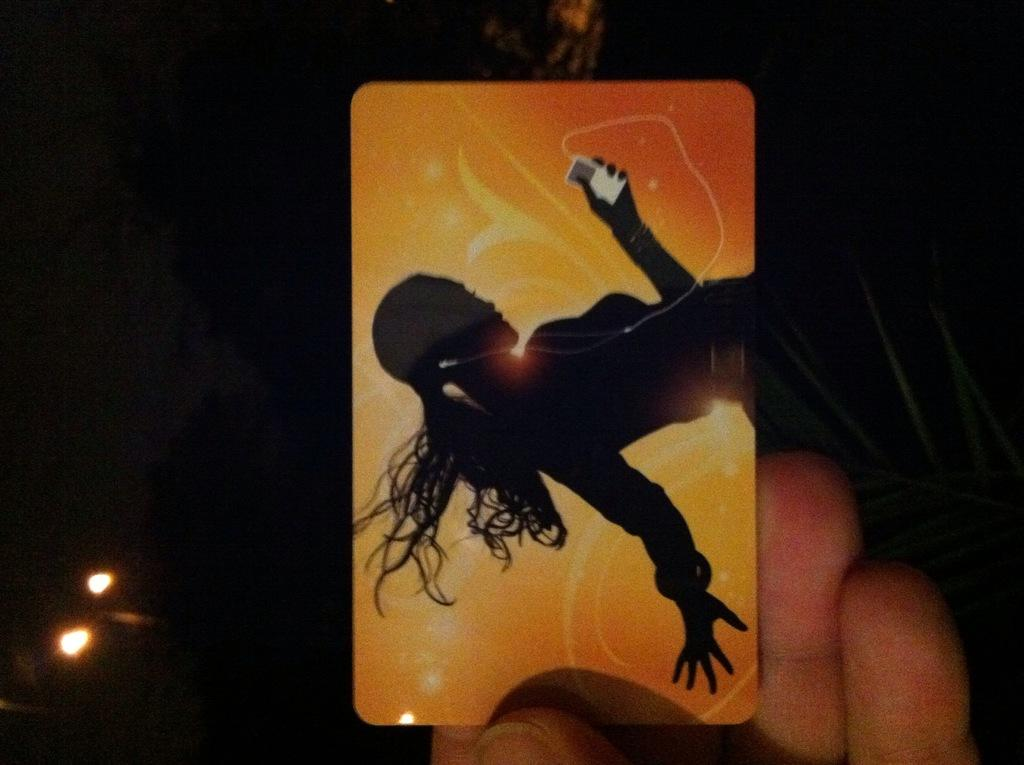What is the person in the image holding? The person in the image is holding a card. What can be seen on the card? The card has an image of a lady holding an object. What can be seen in the background of the image? There are lights visible in the background of the image. What type of trousers is the person wearing in the image? There is no information about the person's trousers in the image, so it cannot be determined. 